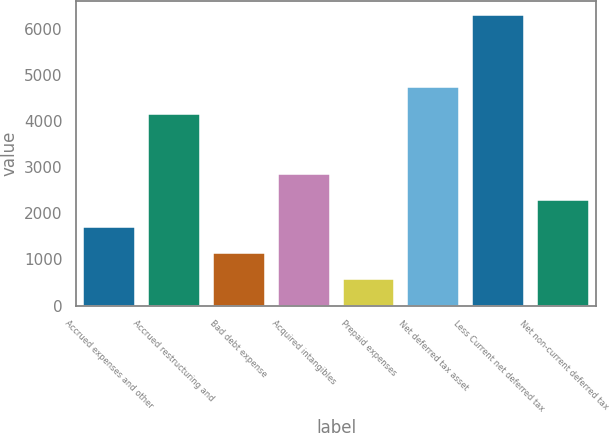<chart> <loc_0><loc_0><loc_500><loc_500><bar_chart><fcel>Accrued expenses and other<fcel>Accrued restructuring and<fcel>Bad debt expense<fcel>Acquired intangibles<fcel>Prepaid expenses<fcel>Net deferred tax asset<fcel>Less Current net deferred tax<fcel>Net non-current deferred tax<nl><fcel>1713<fcel>4159<fcel>1141<fcel>2857<fcel>569<fcel>4731<fcel>6289<fcel>2285<nl></chart> 